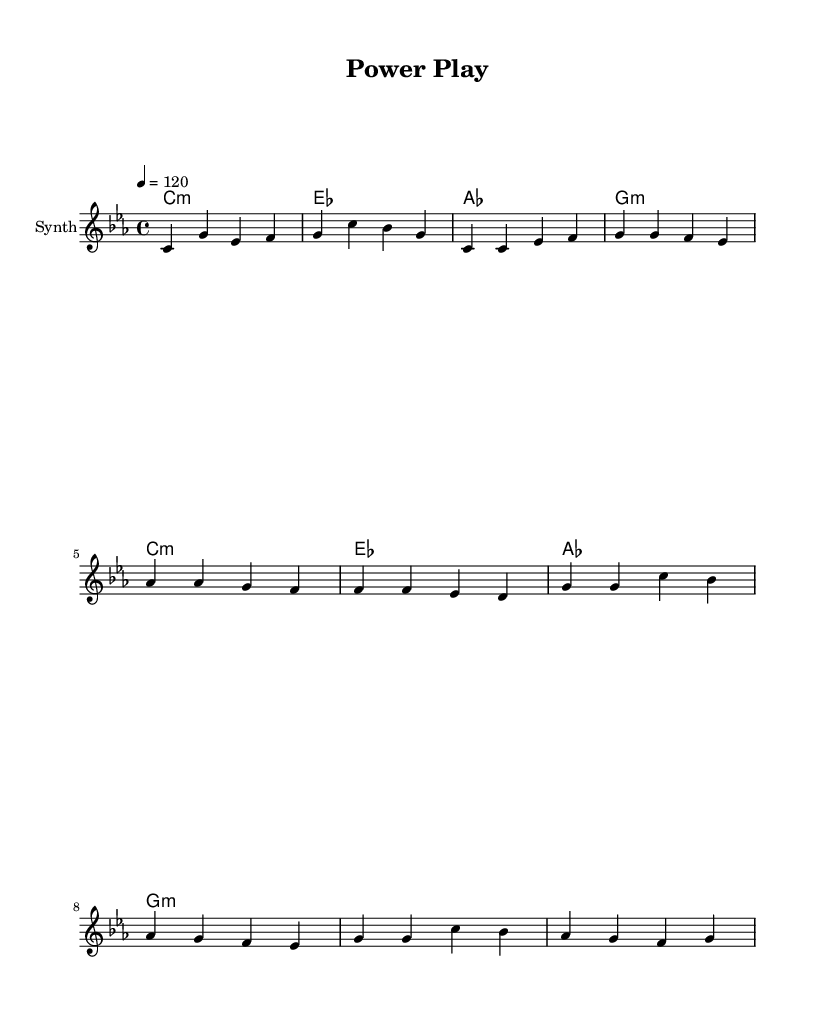What is the key signature of this music? The key signature indicated in the score is C minor, which contains three flats (B♭, E♭, and A♭).
Answer: C minor What is the time signature of this piece? The time signature is shown at the beginning of the score, which indicates how many beats are in each measure; here, it is 4/4.
Answer: 4/4 What is the tempo marking of the music? The tempo marking is indicated by the number 120, showing that the piece should be played at a speed of 120 beats per minute.
Answer: 120 What is the name of the instrument for the melody? The score specifies the instrument for the melody as "Synth," indicating it is electronically produced.
Answer: Synth How many measures are there in the chorus section? By counting the measures represented in the chorus part, there are four measures in total.
Answer: 4 What chord follows the melody notes in the first measure? The first measure's chord is labeled, indicating it corresponds to C minor, which is also shown as c1:m in the chord progression.
Answer: C minor What kind of musical genre does "Power Play" suggest? Given the use of electronic sounds and the style of composition focused on rhythmic beats with political undertones, it suggests contemporary electronic music.
Answer: Contemporary electronic music 